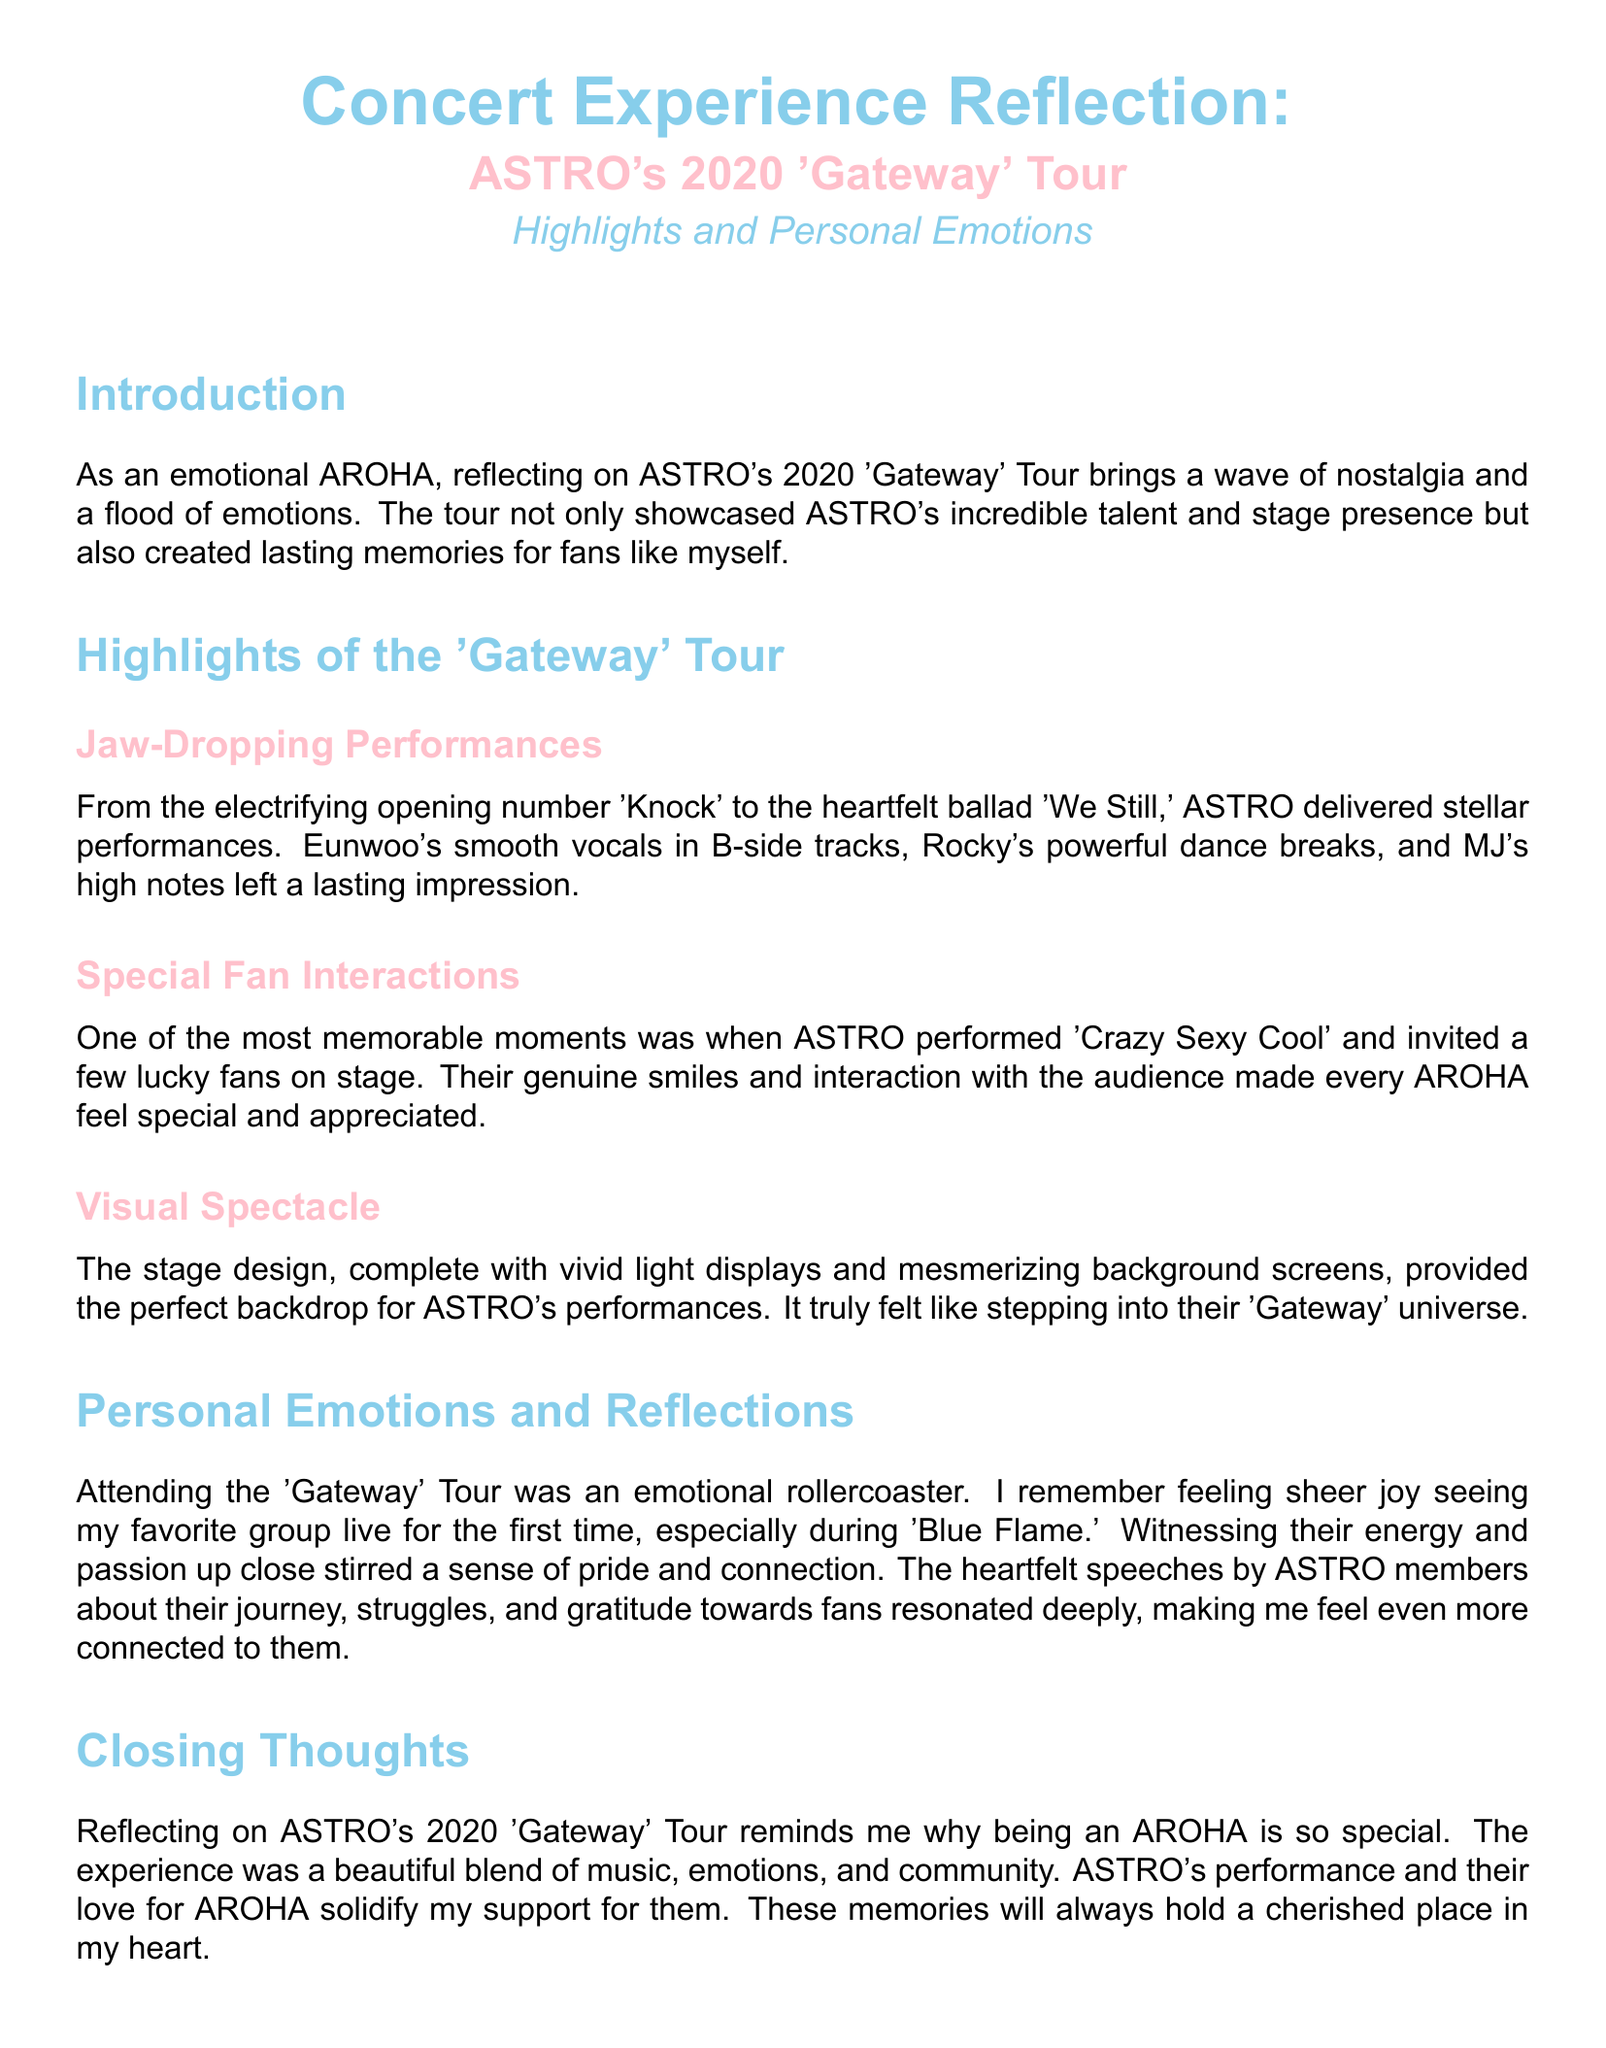what is the title of the concert reflection? The title is explicitly mentioned at the top of the document.
Answer: Concert Experience Reflection what was the opening performance song? The document specifies the electrifying opening number performed by ASTRO.
Answer: Knock which ASTRO member had powerful dance breaks? The document mentions a specific member known for powerful dance breaks.
Answer: Rocky what type of emotions did the experience evoke? The introduction reflects the overall emotional impact of the concert experience.
Answer: Nostalgia what was the name of the heartfelt ballad performed? The document includes the name of a specific ballad performed during the tour.
Answer: We Still how did ASTRO interact with fans during the concert? The document describes a specific interaction where fans were invited on stage.
Answer: Invited fans on stage what did the stage design include? The document outlines elements that contributed to the visual experience of the concert.
Answer: Vivid light displays which song brought the feeling of sheer joy? The specific song that evoked a strong positive emotion is mentioned in the personal reflection.
Answer: Blue Flame what type of community feeling did the concert evoke? The closing thoughts describe the overarching theme of community and support.
Answer: Community 